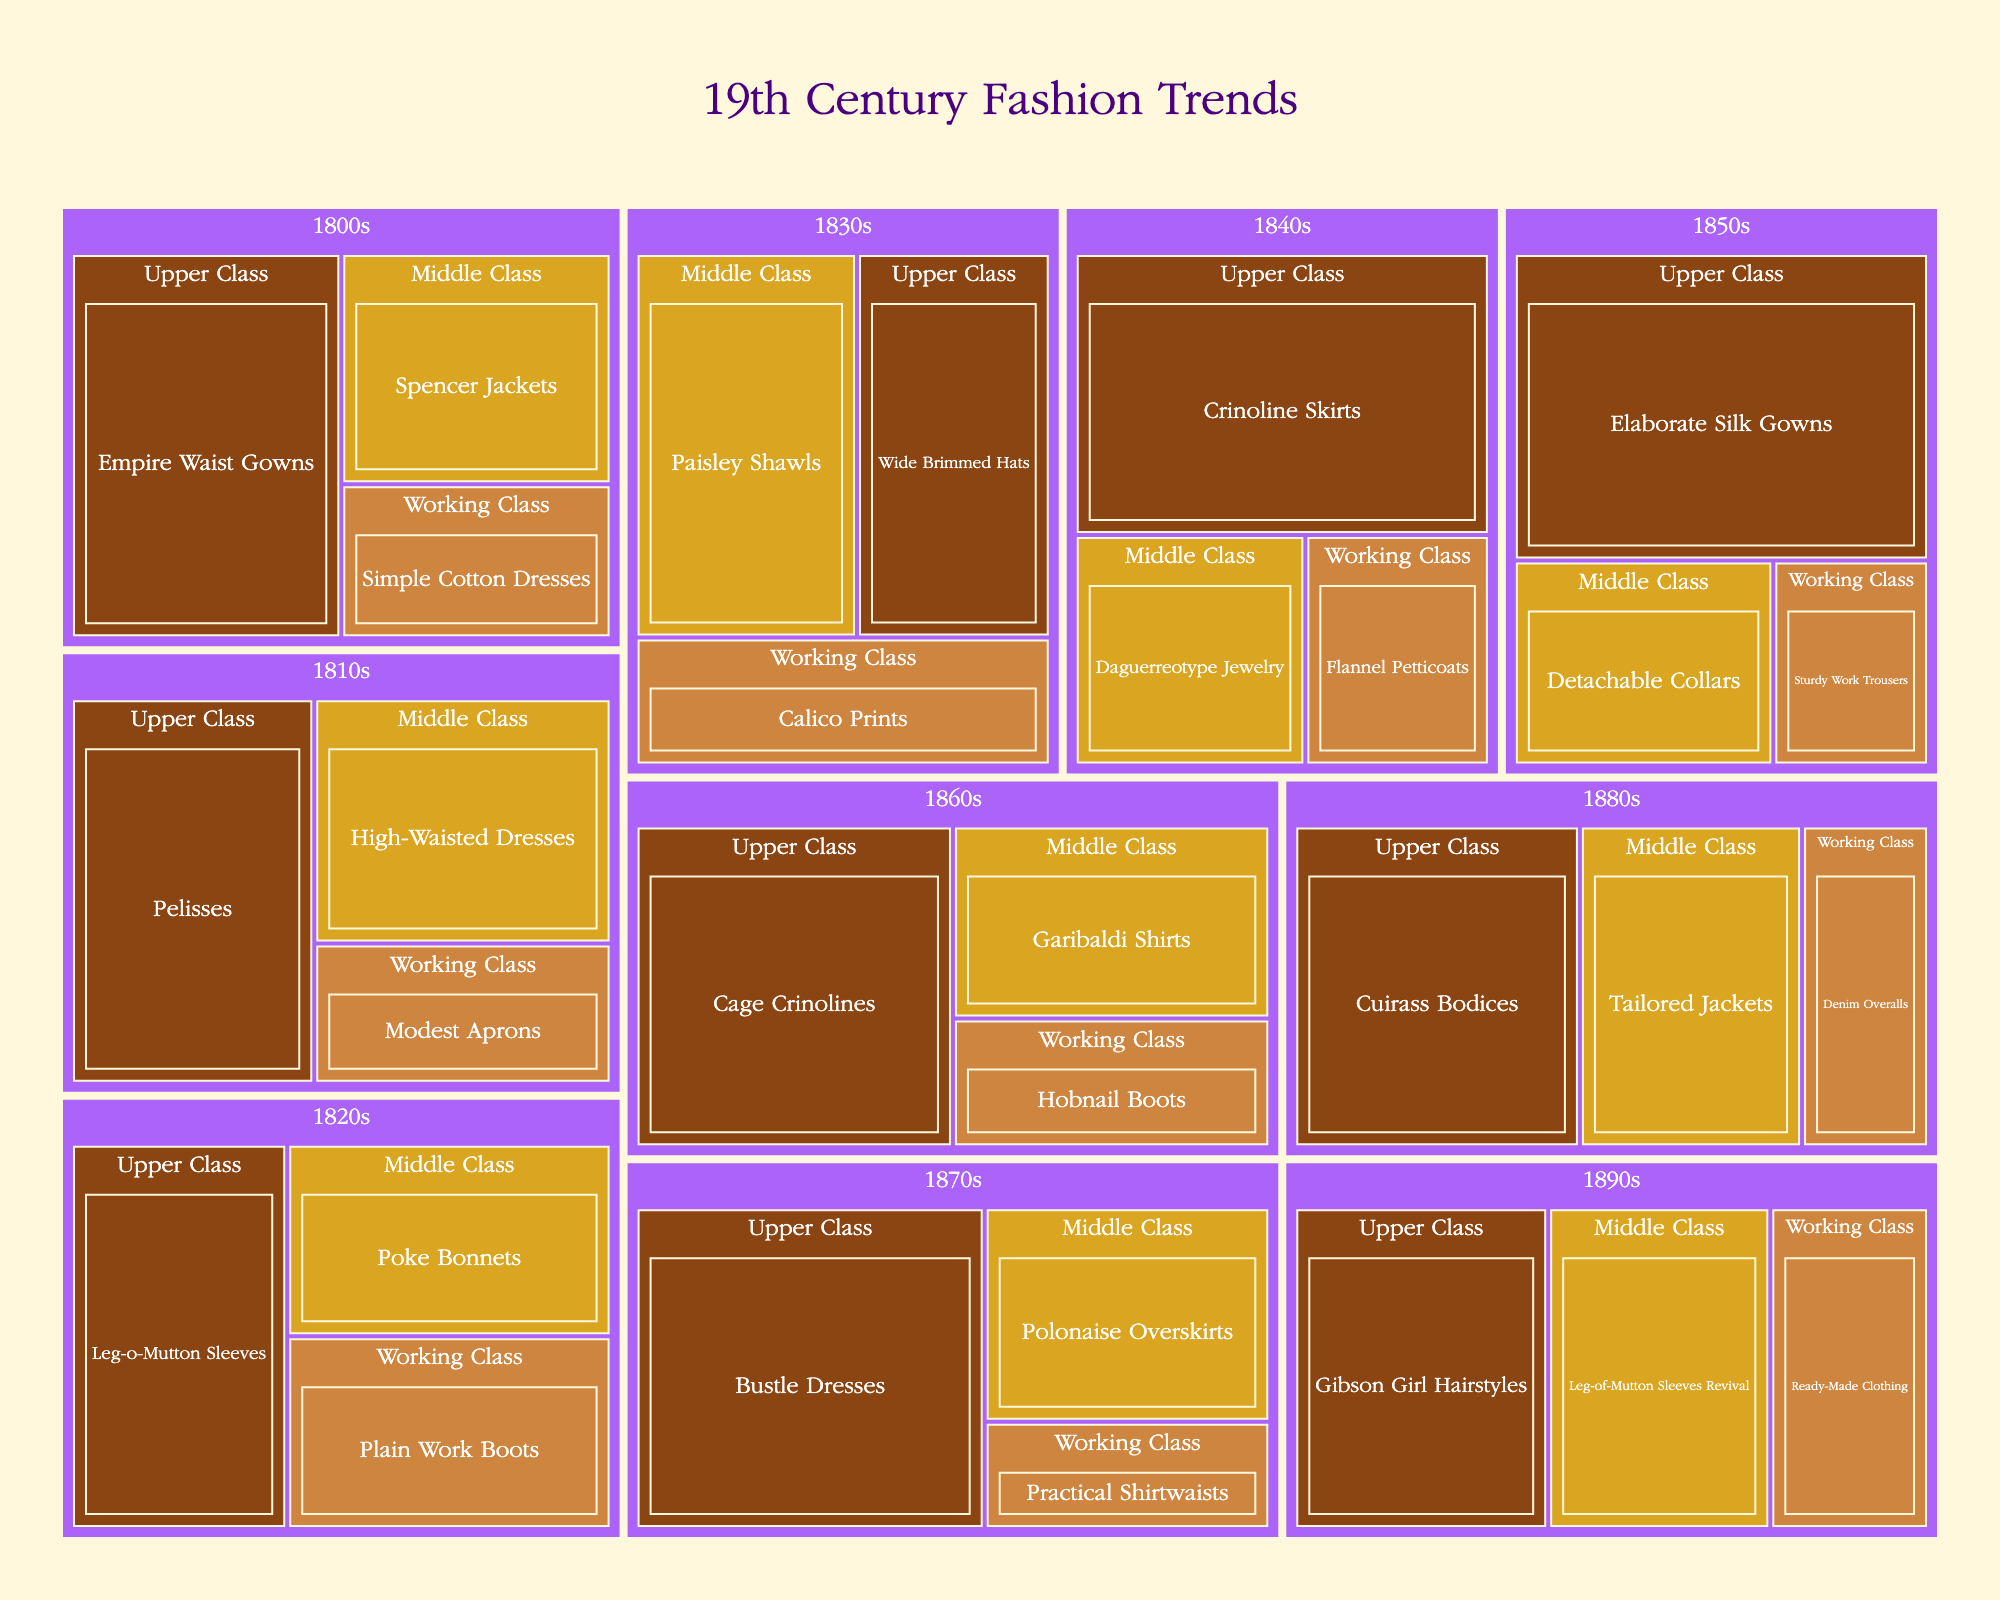What is the title of the treemap? The title of the treemap is usually displayed at the top of the figure and provides a summary of what the visual represents. In this case, it should be referring to the subject of 19th-century fashion trends.
Answer: 19th Century Fashion Trends Which social class had the most popular fashion trend in the 1850s? The size of the boxes in the treemap indicates the popularity of fashion trends. Look at the 1850s section and identify which social class has the largest box.
Answer: Upper Class What is the most popular fashion trend in the 1840s? Locate the 1840s section in the treemap and find the fashion trend with the largest box, as this represents the highest popularity.
Answer: Crinoline Skirts Which decade had the highest variety of fashion trends shown in the treemap? Count the number of distinct fashion trends under each decade by examining the sub-segments in the treemap. The decade with the most sub-segments has the highest variety.
Answer: 1830s Comparing the 1810s and 1890s, which decade had a higher number of fashion trends for the Middle Class? Check the 1810s and 1890s sections in the treemap and count the number of fashion trends listed under the Middle Class for each decade.
Answer: 1810s What is the total popularity value for the Working Class fashion trends in the 1860s? Sum the popularity values of all Working Class fashion trends listed under the 1860s section in the treemap.
Answer: 20 Which decade features "Practical Shirtwaists" as a fashion trend? Scan through the treemap, focusing on the labels within each decade section to find the specific trend "Practical Shirtwaists."
Answer: 1870s Do the Upper Class fashion trends of the 1880s appear to be more popular than those in the 1810s? Compare the sizes of the boxes representing Upper Class fashion trends in the 1880s and 1810s. Larger boxes indicate higher popularity.
Answer: Yes What is the least popular fashion trend for the Upper Class in the 1830s? Identify the fashion trends listed under Upper Class in the 1830s and find the one with the smallest box representing the lowest popularity.
Answer: Wide Brimmed Hats Is there a clear difference in the variety of fashion trends between the Upper Class and Working Class in the 1820s? Count the number of fashion trends for both the Upper Class and Working Class in the 1820s and compare these counts to assess the variety.
Answer: Yes 